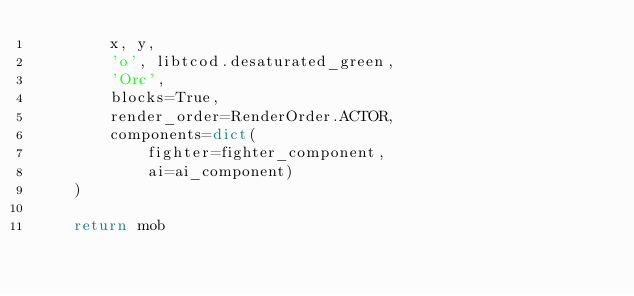Convert code to text. <code><loc_0><loc_0><loc_500><loc_500><_Python_>        x, y,
        'o', libtcod.desaturated_green,
        'Orc',
        blocks=True,
        render_order=RenderOrder.ACTOR,
        components=dict(
            fighter=fighter_component,
            ai=ai_component)
    )

    return mob
</code> 